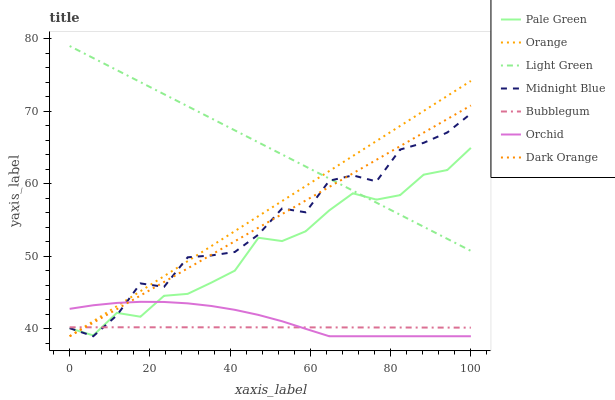Does Bubblegum have the minimum area under the curve?
Answer yes or no. Yes. Does Light Green have the maximum area under the curve?
Answer yes or no. Yes. Does Midnight Blue have the minimum area under the curve?
Answer yes or no. No. Does Midnight Blue have the maximum area under the curve?
Answer yes or no. No. Is Light Green the smoothest?
Answer yes or no. Yes. Is Midnight Blue the roughest?
Answer yes or no. Yes. Is Bubblegum the smoothest?
Answer yes or no. No. Is Bubblegum the roughest?
Answer yes or no. No. Does Bubblegum have the lowest value?
Answer yes or no. No. Does Midnight Blue have the highest value?
Answer yes or no. No. Is Bubblegum less than Light Green?
Answer yes or no. Yes. Is Light Green greater than Orchid?
Answer yes or no. Yes. Does Bubblegum intersect Light Green?
Answer yes or no. No. 